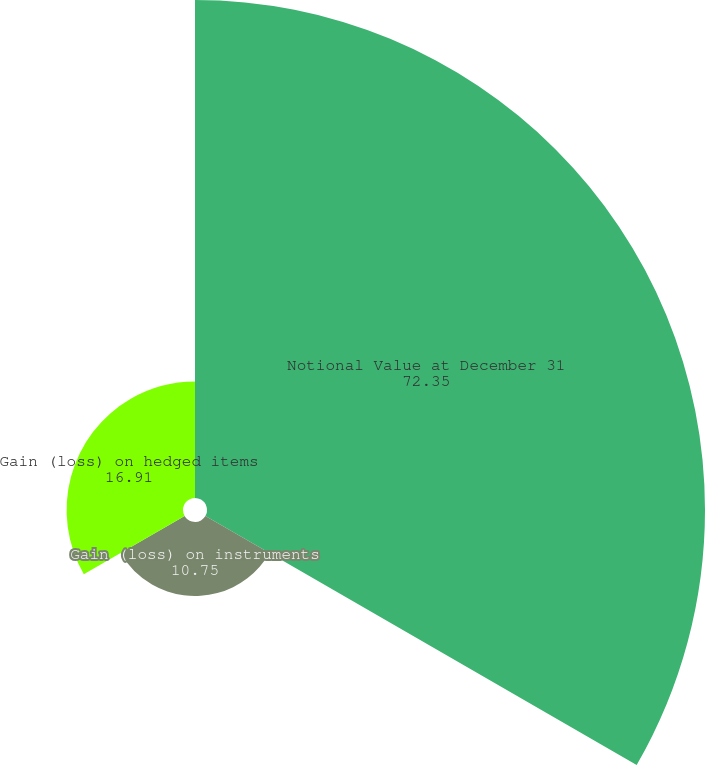<chart> <loc_0><loc_0><loc_500><loc_500><pie_chart><fcel>Notional Value at December 31<fcel>Gain (loss) on instruments<fcel>Gain (loss) on hedged items<nl><fcel>72.35%<fcel>10.75%<fcel>16.91%<nl></chart> 